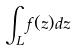<formula> <loc_0><loc_0><loc_500><loc_500>\int _ { L } f ( z ) d z</formula> 